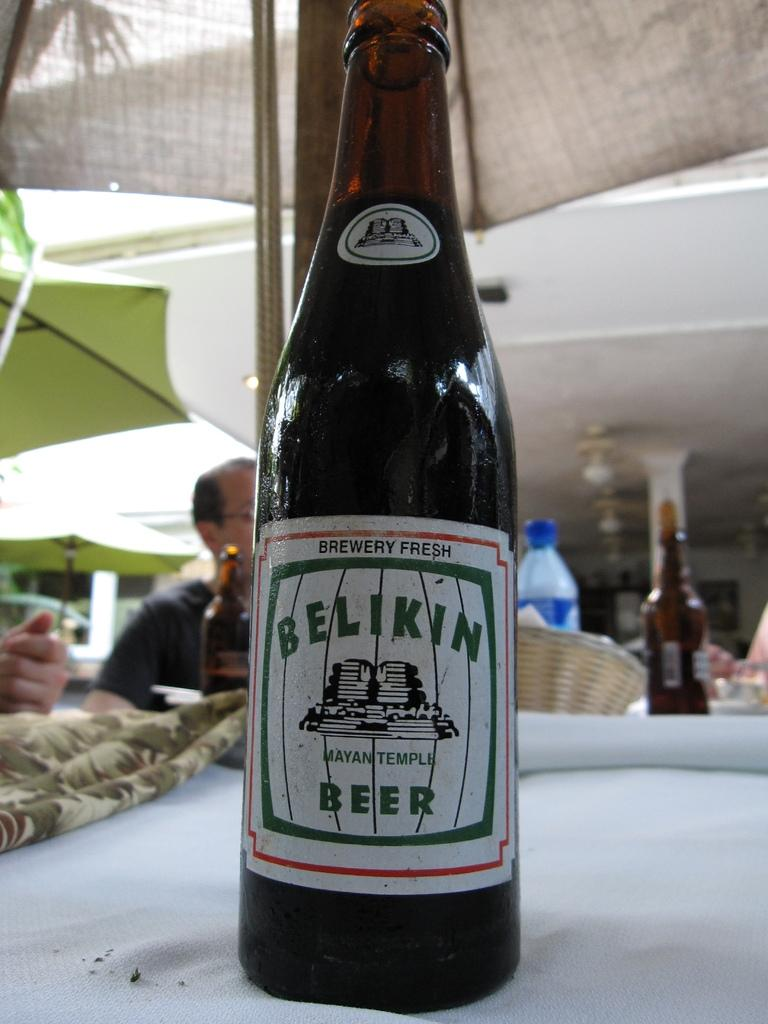<image>
Write a terse but informative summary of the picture. A bottle of Belkin beer with a man in the background. 